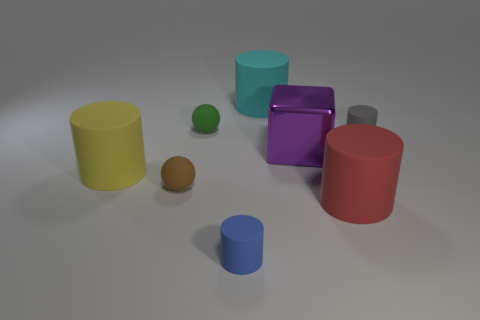Are there any red things that are behind the cylinder behind the green thing?
Offer a terse response. No. There is a blue object; what number of cylinders are behind it?
Offer a terse response. 4. How many other things are there of the same color as the big cube?
Your answer should be compact. 0. Are there fewer cubes behind the green rubber object than rubber things in front of the purple metallic cube?
Offer a very short reply. Yes. How many objects are matte objects in front of the gray object or yellow things?
Your answer should be very brief. 4. There is a purple thing; is it the same size as the sphere that is in front of the cube?
Provide a short and direct response. No. There is a brown matte object that is the same shape as the small green matte object; what is its size?
Provide a succinct answer. Small. There is a small matte cylinder that is left of the large cylinder that is in front of the yellow rubber thing; how many large cylinders are to the right of it?
Offer a very short reply. 2. How many cylinders are large blue matte things or cyan objects?
Make the answer very short. 1. The rubber cylinder that is left of the tiny cylinder left of the large matte cylinder that is in front of the brown thing is what color?
Make the answer very short. Yellow. 